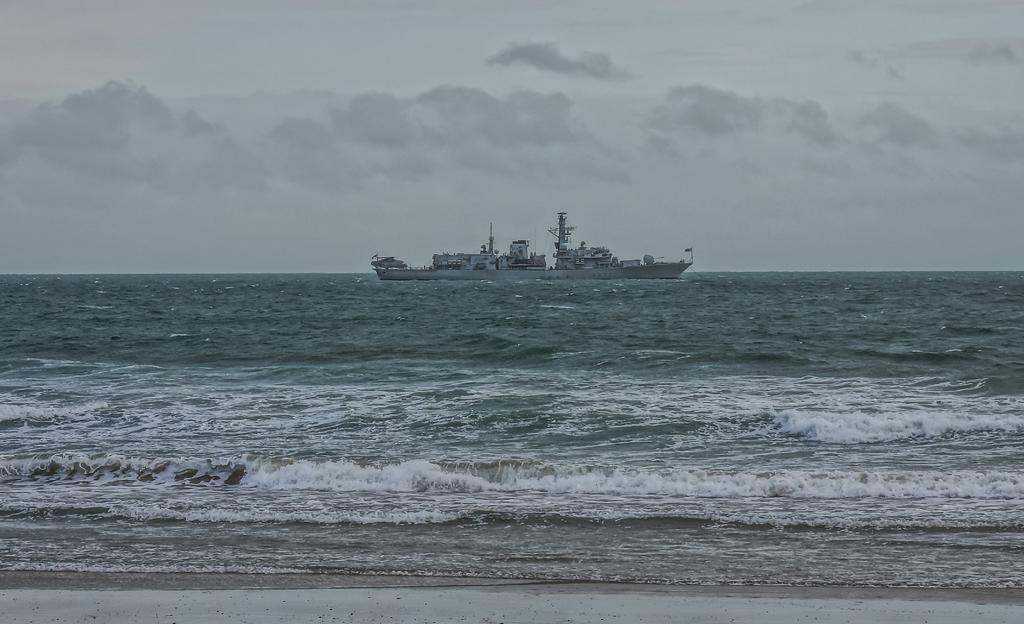What is the main subject of the image? The main subject of the image is a ship. Where is the ship located in the image? The ship is on water in the image. What can be seen in the background of the image? There is a sky visible in the background of the image. What is the condition of the sky in the image? The sky contains clouds in the image. What type of loaf can be seen floating near the ship in the image? There is no loaf present in the image; it features a ship on water. How does the ship transport the waves in the image? The ship does not transport waves; it is a stationary subject in the image. 